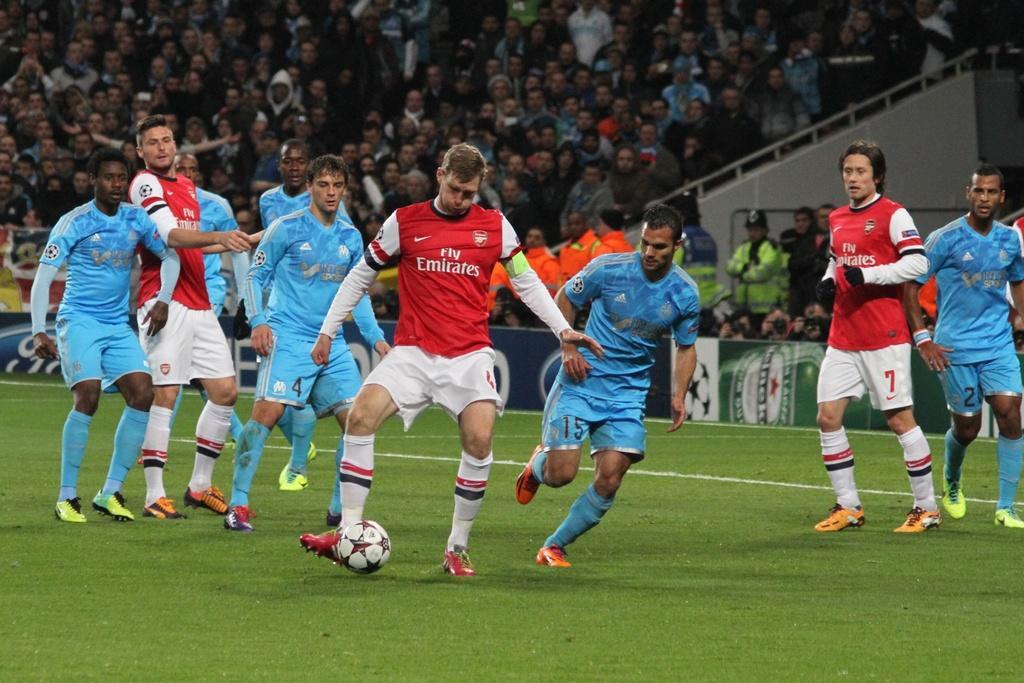Can you describe this image briefly? In this image there are persons playing a game. In the background there a group of persons standing and sitting and there are persons holding camera and there are boards with some text and symbols on it. 